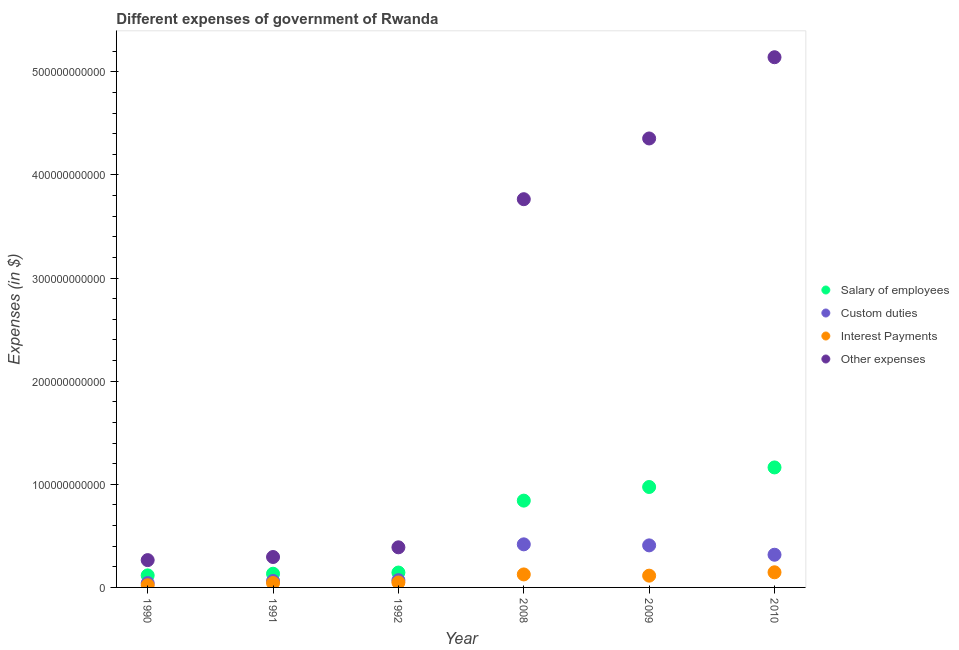What is the amount spent on other expenses in 2010?
Your answer should be very brief. 5.14e+11. Across all years, what is the maximum amount spent on interest payments?
Your answer should be compact. 1.47e+1. Across all years, what is the minimum amount spent on interest payments?
Provide a succinct answer. 2.13e+09. In which year was the amount spent on custom duties maximum?
Ensure brevity in your answer.  2008. What is the total amount spent on custom duties in the graph?
Ensure brevity in your answer.  1.32e+11. What is the difference between the amount spent on interest payments in 1992 and that in 2009?
Offer a very short reply. -6.61e+09. What is the difference between the amount spent on interest payments in 2010 and the amount spent on salary of employees in 1991?
Give a very brief answer. 1.39e+09. What is the average amount spent on other expenses per year?
Provide a short and direct response. 2.37e+11. In the year 1990, what is the difference between the amount spent on other expenses and amount spent on interest payments?
Offer a terse response. 2.44e+1. What is the ratio of the amount spent on salary of employees in 1991 to that in 1992?
Offer a very short reply. 0.92. What is the difference between the highest and the second highest amount spent on custom duties?
Your answer should be very brief. 9.98e+08. What is the difference between the highest and the lowest amount spent on interest payments?
Give a very brief answer. 1.25e+1. In how many years, is the amount spent on custom duties greater than the average amount spent on custom duties taken over all years?
Give a very brief answer. 3. Does the amount spent on salary of employees monotonically increase over the years?
Your response must be concise. Yes. Is the amount spent on custom duties strictly less than the amount spent on other expenses over the years?
Give a very brief answer. Yes. What is the difference between two consecutive major ticks on the Y-axis?
Your answer should be very brief. 1.00e+11. Are the values on the major ticks of Y-axis written in scientific E-notation?
Offer a very short reply. No. Does the graph contain grids?
Offer a terse response. No. Where does the legend appear in the graph?
Keep it short and to the point. Center right. What is the title of the graph?
Offer a very short reply. Different expenses of government of Rwanda. Does "WHO" appear as one of the legend labels in the graph?
Your response must be concise. No. What is the label or title of the X-axis?
Provide a short and direct response. Year. What is the label or title of the Y-axis?
Give a very brief answer. Expenses (in $). What is the Expenses (in $) in Salary of employees in 1990?
Your response must be concise. 1.17e+1. What is the Expenses (in $) in Custom duties in 1990?
Your response must be concise. 4.21e+09. What is the Expenses (in $) of Interest Payments in 1990?
Provide a short and direct response. 2.13e+09. What is the Expenses (in $) of Other expenses in 1990?
Your answer should be very brief. 2.65e+1. What is the Expenses (in $) of Salary of employees in 1991?
Provide a succinct answer. 1.33e+1. What is the Expenses (in $) of Custom duties in 1991?
Provide a short and direct response. 6.24e+09. What is the Expenses (in $) of Interest Payments in 1991?
Your answer should be compact. 4.29e+09. What is the Expenses (in $) in Other expenses in 1991?
Offer a terse response. 2.95e+1. What is the Expenses (in $) of Salary of employees in 1992?
Your answer should be compact. 1.44e+1. What is the Expenses (in $) of Custom duties in 1992?
Your answer should be very brief. 7.04e+09. What is the Expenses (in $) in Interest Payments in 1992?
Your answer should be very brief. 4.80e+09. What is the Expenses (in $) in Other expenses in 1992?
Your answer should be compact. 3.89e+1. What is the Expenses (in $) in Salary of employees in 2008?
Your answer should be compact. 8.42e+1. What is the Expenses (in $) of Custom duties in 2008?
Offer a very short reply. 4.18e+1. What is the Expenses (in $) of Interest Payments in 2008?
Make the answer very short. 1.26e+1. What is the Expenses (in $) of Other expenses in 2008?
Ensure brevity in your answer.  3.77e+11. What is the Expenses (in $) in Salary of employees in 2009?
Your answer should be very brief. 9.74e+1. What is the Expenses (in $) of Custom duties in 2009?
Offer a terse response. 4.08e+1. What is the Expenses (in $) in Interest Payments in 2009?
Make the answer very short. 1.14e+1. What is the Expenses (in $) in Other expenses in 2009?
Give a very brief answer. 4.35e+11. What is the Expenses (in $) in Salary of employees in 2010?
Provide a succinct answer. 1.16e+11. What is the Expenses (in $) of Custom duties in 2010?
Provide a short and direct response. 3.17e+1. What is the Expenses (in $) of Interest Payments in 2010?
Your response must be concise. 1.47e+1. What is the Expenses (in $) of Other expenses in 2010?
Ensure brevity in your answer.  5.14e+11. Across all years, what is the maximum Expenses (in $) of Salary of employees?
Offer a terse response. 1.16e+11. Across all years, what is the maximum Expenses (in $) of Custom duties?
Your response must be concise. 4.18e+1. Across all years, what is the maximum Expenses (in $) in Interest Payments?
Make the answer very short. 1.47e+1. Across all years, what is the maximum Expenses (in $) in Other expenses?
Make the answer very short. 5.14e+11. Across all years, what is the minimum Expenses (in $) in Salary of employees?
Your answer should be compact. 1.17e+1. Across all years, what is the minimum Expenses (in $) in Custom duties?
Provide a short and direct response. 4.21e+09. Across all years, what is the minimum Expenses (in $) of Interest Payments?
Provide a succinct answer. 2.13e+09. Across all years, what is the minimum Expenses (in $) of Other expenses?
Keep it short and to the point. 2.65e+1. What is the total Expenses (in $) in Salary of employees in the graph?
Offer a terse response. 3.37e+11. What is the total Expenses (in $) in Custom duties in the graph?
Your answer should be compact. 1.32e+11. What is the total Expenses (in $) of Interest Payments in the graph?
Keep it short and to the point. 4.99e+1. What is the total Expenses (in $) in Other expenses in the graph?
Ensure brevity in your answer.  1.42e+12. What is the difference between the Expenses (in $) in Salary of employees in 1990 and that in 1991?
Your answer should be very brief. -1.61e+09. What is the difference between the Expenses (in $) in Custom duties in 1990 and that in 1991?
Keep it short and to the point. -2.04e+09. What is the difference between the Expenses (in $) of Interest Payments in 1990 and that in 1991?
Your answer should be compact. -2.16e+09. What is the difference between the Expenses (in $) of Other expenses in 1990 and that in 1991?
Your response must be concise. -3.02e+09. What is the difference between the Expenses (in $) of Salary of employees in 1990 and that in 1992?
Your response must be concise. -2.76e+09. What is the difference between the Expenses (in $) in Custom duties in 1990 and that in 1992?
Offer a very short reply. -2.84e+09. What is the difference between the Expenses (in $) of Interest Payments in 1990 and that in 1992?
Offer a terse response. -2.67e+09. What is the difference between the Expenses (in $) of Other expenses in 1990 and that in 1992?
Make the answer very short. -1.24e+1. What is the difference between the Expenses (in $) in Salary of employees in 1990 and that in 2008?
Make the answer very short. -7.25e+1. What is the difference between the Expenses (in $) of Custom duties in 1990 and that in 2008?
Offer a very short reply. -3.76e+1. What is the difference between the Expenses (in $) of Interest Payments in 1990 and that in 2008?
Give a very brief answer. -1.05e+1. What is the difference between the Expenses (in $) of Other expenses in 1990 and that in 2008?
Your answer should be very brief. -3.50e+11. What is the difference between the Expenses (in $) in Salary of employees in 1990 and that in 2009?
Give a very brief answer. -8.57e+1. What is the difference between the Expenses (in $) in Custom duties in 1990 and that in 2009?
Give a very brief answer. -3.66e+1. What is the difference between the Expenses (in $) in Interest Payments in 1990 and that in 2009?
Your response must be concise. -9.28e+09. What is the difference between the Expenses (in $) of Other expenses in 1990 and that in 2009?
Your answer should be very brief. -4.09e+11. What is the difference between the Expenses (in $) in Salary of employees in 1990 and that in 2010?
Offer a very short reply. -1.05e+11. What is the difference between the Expenses (in $) in Custom duties in 1990 and that in 2010?
Keep it short and to the point. -2.75e+1. What is the difference between the Expenses (in $) of Interest Payments in 1990 and that in 2010?
Keep it short and to the point. -1.25e+1. What is the difference between the Expenses (in $) in Other expenses in 1990 and that in 2010?
Provide a short and direct response. -4.88e+11. What is the difference between the Expenses (in $) in Salary of employees in 1991 and that in 1992?
Make the answer very short. -1.14e+09. What is the difference between the Expenses (in $) in Custom duties in 1991 and that in 1992?
Your answer should be compact. -7.98e+08. What is the difference between the Expenses (in $) of Interest Payments in 1991 and that in 1992?
Provide a short and direct response. -5.08e+08. What is the difference between the Expenses (in $) in Other expenses in 1991 and that in 1992?
Give a very brief answer. -9.40e+09. What is the difference between the Expenses (in $) in Salary of employees in 1991 and that in 2008?
Make the answer very short. -7.09e+1. What is the difference between the Expenses (in $) in Custom duties in 1991 and that in 2008?
Your answer should be very brief. -3.55e+1. What is the difference between the Expenses (in $) in Interest Payments in 1991 and that in 2008?
Make the answer very short. -8.32e+09. What is the difference between the Expenses (in $) in Other expenses in 1991 and that in 2008?
Ensure brevity in your answer.  -3.47e+11. What is the difference between the Expenses (in $) of Salary of employees in 1991 and that in 2009?
Provide a succinct answer. -8.41e+1. What is the difference between the Expenses (in $) in Custom duties in 1991 and that in 2009?
Ensure brevity in your answer.  -3.45e+1. What is the difference between the Expenses (in $) in Interest Payments in 1991 and that in 2009?
Offer a very short reply. -7.12e+09. What is the difference between the Expenses (in $) of Other expenses in 1991 and that in 2009?
Offer a very short reply. -4.06e+11. What is the difference between the Expenses (in $) of Salary of employees in 1991 and that in 2010?
Give a very brief answer. -1.03e+11. What is the difference between the Expenses (in $) in Custom duties in 1991 and that in 2010?
Ensure brevity in your answer.  -2.55e+1. What is the difference between the Expenses (in $) in Interest Payments in 1991 and that in 2010?
Make the answer very short. -1.04e+1. What is the difference between the Expenses (in $) in Other expenses in 1991 and that in 2010?
Your response must be concise. -4.85e+11. What is the difference between the Expenses (in $) in Salary of employees in 1992 and that in 2008?
Your answer should be very brief. -6.97e+1. What is the difference between the Expenses (in $) of Custom duties in 1992 and that in 2008?
Ensure brevity in your answer.  -3.47e+1. What is the difference between the Expenses (in $) in Interest Payments in 1992 and that in 2008?
Give a very brief answer. -7.81e+09. What is the difference between the Expenses (in $) of Other expenses in 1992 and that in 2008?
Offer a terse response. -3.38e+11. What is the difference between the Expenses (in $) of Salary of employees in 1992 and that in 2009?
Provide a succinct answer. -8.30e+1. What is the difference between the Expenses (in $) in Custom duties in 1992 and that in 2009?
Give a very brief answer. -3.37e+1. What is the difference between the Expenses (in $) of Interest Payments in 1992 and that in 2009?
Give a very brief answer. -6.61e+09. What is the difference between the Expenses (in $) in Other expenses in 1992 and that in 2009?
Give a very brief answer. -3.97e+11. What is the difference between the Expenses (in $) of Salary of employees in 1992 and that in 2010?
Your answer should be very brief. -1.02e+11. What is the difference between the Expenses (in $) in Custom duties in 1992 and that in 2010?
Provide a short and direct response. -2.47e+1. What is the difference between the Expenses (in $) of Interest Payments in 1992 and that in 2010?
Offer a very short reply. -9.88e+09. What is the difference between the Expenses (in $) in Other expenses in 1992 and that in 2010?
Provide a succinct answer. -4.75e+11. What is the difference between the Expenses (in $) in Salary of employees in 2008 and that in 2009?
Make the answer very short. -1.32e+1. What is the difference between the Expenses (in $) in Custom duties in 2008 and that in 2009?
Ensure brevity in your answer.  9.98e+08. What is the difference between the Expenses (in $) of Interest Payments in 2008 and that in 2009?
Your answer should be very brief. 1.20e+09. What is the difference between the Expenses (in $) in Other expenses in 2008 and that in 2009?
Offer a terse response. -5.89e+1. What is the difference between the Expenses (in $) of Salary of employees in 2008 and that in 2010?
Give a very brief answer. -3.22e+1. What is the difference between the Expenses (in $) of Custom duties in 2008 and that in 2010?
Ensure brevity in your answer.  1.01e+1. What is the difference between the Expenses (in $) in Interest Payments in 2008 and that in 2010?
Provide a succinct answer. -2.06e+09. What is the difference between the Expenses (in $) of Other expenses in 2008 and that in 2010?
Your answer should be very brief. -1.38e+11. What is the difference between the Expenses (in $) in Salary of employees in 2009 and that in 2010?
Your response must be concise. -1.90e+1. What is the difference between the Expenses (in $) of Custom duties in 2009 and that in 2010?
Offer a very short reply. 9.08e+09. What is the difference between the Expenses (in $) in Interest Payments in 2009 and that in 2010?
Keep it short and to the point. -3.26e+09. What is the difference between the Expenses (in $) of Other expenses in 2009 and that in 2010?
Keep it short and to the point. -7.88e+1. What is the difference between the Expenses (in $) of Salary of employees in 1990 and the Expenses (in $) of Custom duties in 1991?
Provide a succinct answer. 5.44e+09. What is the difference between the Expenses (in $) in Salary of employees in 1990 and the Expenses (in $) in Interest Payments in 1991?
Your response must be concise. 7.39e+09. What is the difference between the Expenses (in $) in Salary of employees in 1990 and the Expenses (in $) in Other expenses in 1991?
Ensure brevity in your answer.  -1.78e+1. What is the difference between the Expenses (in $) of Custom duties in 1990 and the Expenses (in $) of Interest Payments in 1991?
Ensure brevity in your answer.  -8.60e+07. What is the difference between the Expenses (in $) of Custom duties in 1990 and the Expenses (in $) of Other expenses in 1991?
Make the answer very short. -2.53e+1. What is the difference between the Expenses (in $) of Interest Payments in 1990 and the Expenses (in $) of Other expenses in 1991?
Make the answer very short. -2.74e+1. What is the difference between the Expenses (in $) of Salary of employees in 1990 and the Expenses (in $) of Custom duties in 1992?
Offer a terse response. 4.64e+09. What is the difference between the Expenses (in $) in Salary of employees in 1990 and the Expenses (in $) in Interest Payments in 1992?
Offer a very short reply. 6.88e+09. What is the difference between the Expenses (in $) of Salary of employees in 1990 and the Expenses (in $) of Other expenses in 1992?
Ensure brevity in your answer.  -2.72e+1. What is the difference between the Expenses (in $) in Custom duties in 1990 and the Expenses (in $) in Interest Payments in 1992?
Make the answer very short. -5.94e+08. What is the difference between the Expenses (in $) in Custom duties in 1990 and the Expenses (in $) in Other expenses in 1992?
Provide a succinct answer. -3.47e+1. What is the difference between the Expenses (in $) in Interest Payments in 1990 and the Expenses (in $) in Other expenses in 1992?
Provide a short and direct response. -3.68e+1. What is the difference between the Expenses (in $) in Salary of employees in 1990 and the Expenses (in $) in Custom duties in 2008?
Provide a succinct answer. -3.01e+1. What is the difference between the Expenses (in $) in Salary of employees in 1990 and the Expenses (in $) in Interest Payments in 2008?
Give a very brief answer. -9.32e+08. What is the difference between the Expenses (in $) of Salary of employees in 1990 and the Expenses (in $) of Other expenses in 2008?
Make the answer very short. -3.65e+11. What is the difference between the Expenses (in $) of Custom duties in 1990 and the Expenses (in $) of Interest Payments in 2008?
Provide a succinct answer. -8.41e+09. What is the difference between the Expenses (in $) of Custom duties in 1990 and the Expenses (in $) of Other expenses in 2008?
Ensure brevity in your answer.  -3.72e+11. What is the difference between the Expenses (in $) of Interest Payments in 1990 and the Expenses (in $) of Other expenses in 2008?
Provide a short and direct response. -3.74e+11. What is the difference between the Expenses (in $) of Salary of employees in 1990 and the Expenses (in $) of Custom duties in 2009?
Provide a succinct answer. -2.91e+1. What is the difference between the Expenses (in $) in Salary of employees in 1990 and the Expenses (in $) in Interest Payments in 2009?
Your response must be concise. 2.68e+08. What is the difference between the Expenses (in $) in Salary of employees in 1990 and the Expenses (in $) in Other expenses in 2009?
Give a very brief answer. -4.24e+11. What is the difference between the Expenses (in $) of Custom duties in 1990 and the Expenses (in $) of Interest Payments in 2009?
Offer a terse response. -7.21e+09. What is the difference between the Expenses (in $) of Custom duties in 1990 and the Expenses (in $) of Other expenses in 2009?
Provide a short and direct response. -4.31e+11. What is the difference between the Expenses (in $) of Interest Payments in 1990 and the Expenses (in $) of Other expenses in 2009?
Offer a terse response. -4.33e+11. What is the difference between the Expenses (in $) in Salary of employees in 1990 and the Expenses (in $) in Custom duties in 2010?
Offer a terse response. -2.00e+1. What is the difference between the Expenses (in $) in Salary of employees in 1990 and the Expenses (in $) in Interest Payments in 2010?
Provide a succinct answer. -3.00e+09. What is the difference between the Expenses (in $) in Salary of employees in 1990 and the Expenses (in $) in Other expenses in 2010?
Give a very brief answer. -5.03e+11. What is the difference between the Expenses (in $) of Custom duties in 1990 and the Expenses (in $) of Interest Payments in 2010?
Ensure brevity in your answer.  -1.05e+1. What is the difference between the Expenses (in $) in Custom duties in 1990 and the Expenses (in $) in Other expenses in 2010?
Your response must be concise. -5.10e+11. What is the difference between the Expenses (in $) of Interest Payments in 1990 and the Expenses (in $) of Other expenses in 2010?
Offer a very short reply. -5.12e+11. What is the difference between the Expenses (in $) in Salary of employees in 1991 and the Expenses (in $) in Custom duties in 1992?
Your answer should be very brief. 6.25e+09. What is the difference between the Expenses (in $) of Salary of employees in 1991 and the Expenses (in $) of Interest Payments in 1992?
Offer a terse response. 8.49e+09. What is the difference between the Expenses (in $) in Salary of employees in 1991 and the Expenses (in $) in Other expenses in 1992?
Your response must be concise. -2.56e+1. What is the difference between the Expenses (in $) in Custom duties in 1991 and the Expenses (in $) in Interest Payments in 1992?
Keep it short and to the point. 1.44e+09. What is the difference between the Expenses (in $) in Custom duties in 1991 and the Expenses (in $) in Other expenses in 1992?
Provide a succinct answer. -3.27e+1. What is the difference between the Expenses (in $) in Interest Payments in 1991 and the Expenses (in $) in Other expenses in 1992?
Your answer should be very brief. -3.46e+1. What is the difference between the Expenses (in $) of Salary of employees in 1991 and the Expenses (in $) of Custom duties in 2008?
Offer a very short reply. -2.85e+1. What is the difference between the Expenses (in $) of Salary of employees in 1991 and the Expenses (in $) of Interest Payments in 2008?
Provide a short and direct response. 6.78e+08. What is the difference between the Expenses (in $) in Salary of employees in 1991 and the Expenses (in $) in Other expenses in 2008?
Give a very brief answer. -3.63e+11. What is the difference between the Expenses (in $) of Custom duties in 1991 and the Expenses (in $) of Interest Payments in 2008?
Offer a very short reply. -6.37e+09. What is the difference between the Expenses (in $) in Custom duties in 1991 and the Expenses (in $) in Other expenses in 2008?
Your response must be concise. -3.70e+11. What is the difference between the Expenses (in $) in Interest Payments in 1991 and the Expenses (in $) in Other expenses in 2008?
Your answer should be very brief. -3.72e+11. What is the difference between the Expenses (in $) of Salary of employees in 1991 and the Expenses (in $) of Custom duties in 2009?
Ensure brevity in your answer.  -2.75e+1. What is the difference between the Expenses (in $) in Salary of employees in 1991 and the Expenses (in $) in Interest Payments in 2009?
Your answer should be very brief. 1.88e+09. What is the difference between the Expenses (in $) of Salary of employees in 1991 and the Expenses (in $) of Other expenses in 2009?
Keep it short and to the point. -4.22e+11. What is the difference between the Expenses (in $) in Custom duties in 1991 and the Expenses (in $) in Interest Payments in 2009?
Make the answer very short. -5.17e+09. What is the difference between the Expenses (in $) in Custom duties in 1991 and the Expenses (in $) in Other expenses in 2009?
Your response must be concise. -4.29e+11. What is the difference between the Expenses (in $) in Interest Payments in 1991 and the Expenses (in $) in Other expenses in 2009?
Offer a very short reply. -4.31e+11. What is the difference between the Expenses (in $) of Salary of employees in 1991 and the Expenses (in $) of Custom duties in 2010?
Your answer should be compact. -1.84e+1. What is the difference between the Expenses (in $) in Salary of employees in 1991 and the Expenses (in $) in Interest Payments in 2010?
Provide a succinct answer. -1.39e+09. What is the difference between the Expenses (in $) of Salary of employees in 1991 and the Expenses (in $) of Other expenses in 2010?
Offer a terse response. -5.01e+11. What is the difference between the Expenses (in $) in Custom duties in 1991 and the Expenses (in $) in Interest Payments in 2010?
Keep it short and to the point. -8.43e+09. What is the difference between the Expenses (in $) of Custom duties in 1991 and the Expenses (in $) of Other expenses in 2010?
Offer a very short reply. -5.08e+11. What is the difference between the Expenses (in $) in Interest Payments in 1991 and the Expenses (in $) in Other expenses in 2010?
Give a very brief answer. -5.10e+11. What is the difference between the Expenses (in $) of Salary of employees in 1992 and the Expenses (in $) of Custom duties in 2008?
Your response must be concise. -2.73e+1. What is the difference between the Expenses (in $) of Salary of employees in 1992 and the Expenses (in $) of Interest Payments in 2008?
Give a very brief answer. 1.82e+09. What is the difference between the Expenses (in $) of Salary of employees in 1992 and the Expenses (in $) of Other expenses in 2008?
Your answer should be compact. -3.62e+11. What is the difference between the Expenses (in $) of Custom duties in 1992 and the Expenses (in $) of Interest Payments in 2008?
Your answer should be compact. -5.57e+09. What is the difference between the Expenses (in $) in Custom duties in 1992 and the Expenses (in $) in Other expenses in 2008?
Your answer should be very brief. -3.69e+11. What is the difference between the Expenses (in $) of Interest Payments in 1992 and the Expenses (in $) of Other expenses in 2008?
Ensure brevity in your answer.  -3.72e+11. What is the difference between the Expenses (in $) of Salary of employees in 1992 and the Expenses (in $) of Custom duties in 2009?
Your response must be concise. -2.63e+1. What is the difference between the Expenses (in $) of Salary of employees in 1992 and the Expenses (in $) of Interest Payments in 2009?
Provide a succinct answer. 3.02e+09. What is the difference between the Expenses (in $) of Salary of employees in 1992 and the Expenses (in $) of Other expenses in 2009?
Offer a terse response. -4.21e+11. What is the difference between the Expenses (in $) of Custom duties in 1992 and the Expenses (in $) of Interest Payments in 2009?
Your response must be concise. -4.37e+09. What is the difference between the Expenses (in $) of Custom duties in 1992 and the Expenses (in $) of Other expenses in 2009?
Offer a very short reply. -4.28e+11. What is the difference between the Expenses (in $) of Interest Payments in 1992 and the Expenses (in $) of Other expenses in 2009?
Your answer should be very brief. -4.31e+11. What is the difference between the Expenses (in $) in Salary of employees in 1992 and the Expenses (in $) in Custom duties in 2010?
Offer a very short reply. -1.73e+1. What is the difference between the Expenses (in $) in Salary of employees in 1992 and the Expenses (in $) in Interest Payments in 2010?
Provide a succinct answer. -2.40e+08. What is the difference between the Expenses (in $) of Salary of employees in 1992 and the Expenses (in $) of Other expenses in 2010?
Ensure brevity in your answer.  -5.00e+11. What is the difference between the Expenses (in $) in Custom duties in 1992 and the Expenses (in $) in Interest Payments in 2010?
Your response must be concise. -7.63e+09. What is the difference between the Expenses (in $) in Custom duties in 1992 and the Expenses (in $) in Other expenses in 2010?
Give a very brief answer. -5.07e+11. What is the difference between the Expenses (in $) of Interest Payments in 1992 and the Expenses (in $) of Other expenses in 2010?
Provide a short and direct response. -5.09e+11. What is the difference between the Expenses (in $) in Salary of employees in 2008 and the Expenses (in $) in Custom duties in 2009?
Offer a very short reply. 4.34e+1. What is the difference between the Expenses (in $) in Salary of employees in 2008 and the Expenses (in $) in Interest Payments in 2009?
Provide a succinct answer. 7.28e+1. What is the difference between the Expenses (in $) in Salary of employees in 2008 and the Expenses (in $) in Other expenses in 2009?
Give a very brief answer. -3.51e+11. What is the difference between the Expenses (in $) of Custom duties in 2008 and the Expenses (in $) of Interest Payments in 2009?
Ensure brevity in your answer.  3.04e+1. What is the difference between the Expenses (in $) of Custom duties in 2008 and the Expenses (in $) of Other expenses in 2009?
Offer a terse response. -3.94e+11. What is the difference between the Expenses (in $) in Interest Payments in 2008 and the Expenses (in $) in Other expenses in 2009?
Make the answer very short. -4.23e+11. What is the difference between the Expenses (in $) in Salary of employees in 2008 and the Expenses (in $) in Custom duties in 2010?
Offer a terse response. 5.25e+1. What is the difference between the Expenses (in $) of Salary of employees in 2008 and the Expenses (in $) of Interest Payments in 2010?
Your answer should be very brief. 6.95e+1. What is the difference between the Expenses (in $) in Salary of employees in 2008 and the Expenses (in $) in Other expenses in 2010?
Make the answer very short. -4.30e+11. What is the difference between the Expenses (in $) of Custom duties in 2008 and the Expenses (in $) of Interest Payments in 2010?
Make the answer very short. 2.71e+1. What is the difference between the Expenses (in $) of Custom duties in 2008 and the Expenses (in $) of Other expenses in 2010?
Provide a short and direct response. -4.72e+11. What is the difference between the Expenses (in $) in Interest Payments in 2008 and the Expenses (in $) in Other expenses in 2010?
Your answer should be very brief. -5.02e+11. What is the difference between the Expenses (in $) in Salary of employees in 2009 and the Expenses (in $) in Custom duties in 2010?
Your answer should be compact. 6.57e+1. What is the difference between the Expenses (in $) in Salary of employees in 2009 and the Expenses (in $) in Interest Payments in 2010?
Your answer should be compact. 8.27e+1. What is the difference between the Expenses (in $) of Salary of employees in 2009 and the Expenses (in $) of Other expenses in 2010?
Ensure brevity in your answer.  -4.17e+11. What is the difference between the Expenses (in $) in Custom duties in 2009 and the Expenses (in $) in Interest Payments in 2010?
Offer a terse response. 2.61e+1. What is the difference between the Expenses (in $) in Custom duties in 2009 and the Expenses (in $) in Other expenses in 2010?
Offer a very short reply. -4.73e+11. What is the difference between the Expenses (in $) of Interest Payments in 2009 and the Expenses (in $) of Other expenses in 2010?
Offer a very short reply. -5.03e+11. What is the average Expenses (in $) of Salary of employees per year?
Your answer should be very brief. 5.62e+1. What is the average Expenses (in $) of Custom duties per year?
Your response must be concise. 2.20e+1. What is the average Expenses (in $) of Interest Payments per year?
Your answer should be very brief. 8.32e+09. What is the average Expenses (in $) in Other expenses per year?
Provide a succinct answer. 2.37e+11. In the year 1990, what is the difference between the Expenses (in $) of Salary of employees and Expenses (in $) of Custom duties?
Give a very brief answer. 7.47e+09. In the year 1990, what is the difference between the Expenses (in $) in Salary of employees and Expenses (in $) in Interest Payments?
Provide a succinct answer. 9.55e+09. In the year 1990, what is the difference between the Expenses (in $) of Salary of employees and Expenses (in $) of Other expenses?
Offer a very short reply. -1.48e+1. In the year 1990, what is the difference between the Expenses (in $) in Custom duties and Expenses (in $) in Interest Payments?
Offer a terse response. 2.08e+09. In the year 1990, what is the difference between the Expenses (in $) of Custom duties and Expenses (in $) of Other expenses?
Make the answer very short. -2.23e+1. In the year 1990, what is the difference between the Expenses (in $) in Interest Payments and Expenses (in $) in Other expenses?
Provide a succinct answer. -2.44e+1. In the year 1991, what is the difference between the Expenses (in $) of Salary of employees and Expenses (in $) of Custom duties?
Offer a terse response. 7.05e+09. In the year 1991, what is the difference between the Expenses (in $) of Salary of employees and Expenses (in $) of Interest Payments?
Give a very brief answer. 9.00e+09. In the year 1991, what is the difference between the Expenses (in $) in Salary of employees and Expenses (in $) in Other expenses?
Your response must be concise. -1.62e+1. In the year 1991, what is the difference between the Expenses (in $) in Custom duties and Expenses (in $) in Interest Payments?
Ensure brevity in your answer.  1.95e+09. In the year 1991, what is the difference between the Expenses (in $) in Custom duties and Expenses (in $) in Other expenses?
Provide a succinct answer. -2.33e+1. In the year 1991, what is the difference between the Expenses (in $) in Interest Payments and Expenses (in $) in Other expenses?
Your answer should be compact. -2.52e+1. In the year 1992, what is the difference between the Expenses (in $) of Salary of employees and Expenses (in $) of Custom duties?
Provide a succinct answer. 7.39e+09. In the year 1992, what is the difference between the Expenses (in $) in Salary of employees and Expenses (in $) in Interest Payments?
Give a very brief answer. 9.64e+09. In the year 1992, what is the difference between the Expenses (in $) of Salary of employees and Expenses (in $) of Other expenses?
Ensure brevity in your answer.  -2.45e+1. In the year 1992, what is the difference between the Expenses (in $) in Custom duties and Expenses (in $) in Interest Payments?
Provide a succinct answer. 2.24e+09. In the year 1992, what is the difference between the Expenses (in $) of Custom duties and Expenses (in $) of Other expenses?
Your response must be concise. -3.19e+1. In the year 1992, what is the difference between the Expenses (in $) in Interest Payments and Expenses (in $) in Other expenses?
Offer a very short reply. -3.41e+1. In the year 2008, what is the difference between the Expenses (in $) of Salary of employees and Expenses (in $) of Custom duties?
Provide a short and direct response. 4.24e+1. In the year 2008, what is the difference between the Expenses (in $) of Salary of employees and Expenses (in $) of Interest Payments?
Keep it short and to the point. 7.16e+1. In the year 2008, what is the difference between the Expenses (in $) in Salary of employees and Expenses (in $) in Other expenses?
Provide a short and direct response. -2.92e+11. In the year 2008, what is the difference between the Expenses (in $) in Custom duties and Expenses (in $) in Interest Payments?
Provide a short and direct response. 2.92e+1. In the year 2008, what is the difference between the Expenses (in $) of Custom duties and Expenses (in $) of Other expenses?
Your response must be concise. -3.35e+11. In the year 2008, what is the difference between the Expenses (in $) in Interest Payments and Expenses (in $) in Other expenses?
Offer a very short reply. -3.64e+11. In the year 2009, what is the difference between the Expenses (in $) of Salary of employees and Expenses (in $) of Custom duties?
Your answer should be compact. 5.66e+1. In the year 2009, what is the difference between the Expenses (in $) in Salary of employees and Expenses (in $) in Interest Payments?
Your answer should be compact. 8.60e+1. In the year 2009, what is the difference between the Expenses (in $) of Salary of employees and Expenses (in $) of Other expenses?
Provide a short and direct response. -3.38e+11. In the year 2009, what is the difference between the Expenses (in $) of Custom duties and Expenses (in $) of Interest Payments?
Ensure brevity in your answer.  2.94e+1. In the year 2009, what is the difference between the Expenses (in $) in Custom duties and Expenses (in $) in Other expenses?
Your answer should be very brief. -3.95e+11. In the year 2009, what is the difference between the Expenses (in $) of Interest Payments and Expenses (in $) of Other expenses?
Give a very brief answer. -4.24e+11. In the year 2010, what is the difference between the Expenses (in $) in Salary of employees and Expenses (in $) in Custom duties?
Offer a very short reply. 8.47e+1. In the year 2010, what is the difference between the Expenses (in $) in Salary of employees and Expenses (in $) in Interest Payments?
Provide a short and direct response. 1.02e+11. In the year 2010, what is the difference between the Expenses (in $) in Salary of employees and Expenses (in $) in Other expenses?
Your answer should be very brief. -3.98e+11. In the year 2010, what is the difference between the Expenses (in $) of Custom duties and Expenses (in $) of Interest Payments?
Offer a terse response. 1.70e+1. In the year 2010, what is the difference between the Expenses (in $) of Custom duties and Expenses (in $) of Other expenses?
Your answer should be very brief. -4.83e+11. In the year 2010, what is the difference between the Expenses (in $) in Interest Payments and Expenses (in $) in Other expenses?
Give a very brief answer. -5.00e+11. What is the ratio of the Expenses (in $) in Salary of employees in 1990 to that in 1991?
Give a very brief answer. 0.88. What is the ratio of the Expenses (in $) in Custom duties in 1990 to that in 1991?
Your response must be concise. 0.67. What is the ratio of the Expenses (in $) of Interest Payments in 1990 to that in 1991?
Offer a very short reply. 0.5. What is the ratio of the Expenses (in $) in Other expenses in 1990 to that in 1991?
Give a very brief answer. 0.9. What is the ratio of the Expenses (in $) of Salary of employees in 1990 to that in 1992?
Make the answer very short. 0.81. What is the ratio of the Expenses (in $) of Custom duties in 1990 to that in 1992?
Offer a terse response. 0.6. What is the ratio of the Expenses (in $) in Interest Payments in 1990 to that in 1992?
Offer a very short reply. 0.44. What is the ratio of the Expenses (in $) of Other expenses in 1990 to that in 1992?
Your answer should be compact. 0.68. What is the ratio of the Expenses (in $) in Salary of employees in 1990 to that in 2008?
Give a very brief answer. 0.14. What is the ratio of the Expenses (in $) of Custom duties in 1990 to that in 2008?
Keep it short and to the point. 0.1. What is the ratio of the Expenses (in $) in Interest Payments in 1990 to that in 2008?
Your answer should be compact. 0.17. What is the ratio of the Expenses (in $) in Other expenses in 1990 to that in 2008?
Provide a short and direct response. 0.07. What is the ratio of the Expenses (in $) of Salary of employees in 1990 to that in 2009?
Offer a very short reply. 0.12. What is the ratio of the Expenses (in $) of Custom duties in 1990 to that in 2009?
Your response must be concise. 0.1. What is the ratio of the Expenses (in $) of Interest Payments in 1990 to that in 2009?
Give a very brief answer. 0.19. What is the ratio of the Expenses (in $) in Other expenses in 1990 to that in 2009?
Offer a very short reply. 0.06. What is the ratio of the Expenses (in $) of Salary of employees in 1990 to that in 2010?
Offer a very short reply. 0.1. What is the ratio of the Expenses (in $) of Custom duties in 1990 to that in 2010?
Keep it short and to the point. 0.13. What is the ratio of the Expenses (in $) in Interest Payments in 1990 to that in 2010?
Provide a succinct answer. 0.15. What is the ratio of the Expenses (in $) in Other expenses in 1990 to that in 2010?
Offer a terse response. 0.05. What is the ratio of the Expenses (in $) in Salary of employees in 1991 to that in 1992?
Ensure brevity in your answer.  0.92. What is the ratio of the Expenses (in $) in Custom duties in 1991 to that in 1992?
Offer a very short reply. 0.89. What is the ratio of the Expenses (in $) in Interest Payments in 1991 to that in 1992?
Keep it short and to the point. 0.89. What is the ratio of the Expenses (in $) of Other expenses in 1991 to that in 1992?
Provide a succinct answer. 0.76. What is the ratio of the Expenses (in $) in Salary of employees in 1991 to that in 2008?
Make the answer very short. 0.16. What is the ratio of the Expenses (in $) in Custom duties in 1991 to that in 2008?
Provide a succinct answer. 0.15. What is the ratio of the Expenses (in $) of Interest Payments in 1991 to that in 2008?
Your answer should be very brief. 0.34. What is the ratio of the Expenses (in $) of Other expenses in 1991 to that in 2008?
Ensure brevity in your answer.  0.08. What is the ratio of the Expenses (in $) of Salary of employees in 1991 to that in 2009?
Ensure brevity in your answer.  0.14. What is the ratio of the Expenses (in $) in Custom duties in 1991 to that in 2009?
Provide a short and direct response. 0.15. What is the ratio of the Expenses (in $) in Interest Payments in 1991 to that in 2009?
Provide a short and direct response. 0.38. What is the ratio of the Expenses (in $) in Other expenses in 1991 to that in 2009?
Your answer should be very brief. 0.07. What is the ratio of the Expenses (in $) in Salary of employees in 1991 to that in 2010?
Provide a succinct answer. 0.11. What is the ratio of the Expenses (in $) in Custom duties in 1991 to that in 2010?
Provide a succinct answer. 0.2. What is the ratio of the Expenses (in $) of Interest Payments in 1991 to that in 2010?
Provide a succinct answer. 0.29. What is the ratio of the Expenses (in $) in Other expenses in 1991 to that in 2010?
Give a very brief answer. 0.06. What is the ratio of the Expenses (in $) in Salary of employees in 1992 to that in 2008?
Keep it short and to the point. 0.17. What is the ratio of the Expenses (in $) in Custom duties in 1992 to that in 2008?
Your answer should be very brief. 0.17. What is the ratio of the Expenses (in $) of Interest Payments in 1992 to that in 2008?
Your answer should be very brief. 0.38. What is the ratio of the Expenses (in $) in Other expenses in 1992 to that in 2008?
Keep it short and to the point. 0.1. What is the ratio of the Expenses (in $) of Salary of employees in 1992 to that in 2009?
Your response must be concise. 0.15. What is the ratio of the Expenses (in $) in Custom duties in 1992 to that in 2009?
Your response must be concise. 0.17. What is the ratio of the Expenses (in $) of Interest Payments in 1992 to that in 2009?
Keep it short and to the point. 0.42. What is the ratio of the Expenses (in $) of Other expenses in 1992 to that in 2009?
Your response must be concise. 0.09. What is the ratio of the Expenses (in $) in Salary of employees in 1992 to that in 2010?
Ensure brevity in your answer.  0.12. What is the ratio of the Expenses (in $) in Custom duties in 1992 to that in 2010?
Give a very brief answer. 0.22. What is the ratio of the Expenses (in $) in Interest Payments in 1992 to that in 2010?
Ensure brevity in your answer.  0.33. What is the ratio of the Expenses (in $) of Other expenses in 1992 to that in 2010?
Offer a very short reply. 0.08. What is the ratio of the Expenses (in $) of Salary of employees in 2008 to that in 2009?
Your answer should be compact. 0.86. What is the ratio of the Expenses (in $) of Custom duties in 2008 to that in 2009?
Keep it short and to the point. 1.02. What is the ratio of the Expenses (in $) in Interest Payments in 2008 to that in 2009?
Your response must be concise. 1.11. What is the ratio of the Expenses (in $) in Other expenses in 2008 to that in 2009?
Offer a terse response. 0.86. What is the ratio of the Expenses (in $) in Salary of employees in 2008 to that in 2010?
Offer a very short reply. 0.72. What is the ratio of the Expenses (in $) in Custom duties in 2008 to that in 2010?
Make the answer very short. 1.32. What is the ratio of the Expenses (in $) in Interest Payments in 2008 to that in 2010?
Your answer should be compact. 0.86. What is the ratio of the Expenses (in $) in Other expenses in 2008 to that in 2010?
Provide a short and direct response. 0.73. What is the ratio of the Expenses (in $) in Salary of employees in 2009 to that in 2010?
Your answer should be compact. 0.84. What is the ratio of the Expenses (in $) in Custom duties in 2009 to that in 2010?
Your answer should be very brief. 1.29. What is the ratio of the Expenses (in $) in Interest Payments in 2009 to that in 2010?
Ensure brevity in your answer.  0.78. What is the ratio of the Expenses (in $) of Other expenses in 2009 to that in 2010?
Provide a short and direct response. 0.85. What is the difference between the highest and the second highest Expenses (in $) in Salary of employees?
Your answer should be very brief. 1.90e+1. What is the difference between the highest and the second highest Expenses (in $) in Custom duties?
Your answer should be very brief. 9.98e+08. What is the difference between the highest and the second highest Expenses (in $) in Interest Payments?
Give a very brief answer. 2.06e+09. What is the difference between the highest and the second highest Expenses (in $) of Other expenses?
Your response must be concise. 7.88e+1. What is the difference between the highest and the lowest Expenses (in $) of Salary of employees?
Your response must be concise. 1.05e+11. What is the difference between the highest and the lowest Expenses (in $) of Custom duties?
Ensure brevity in your answer.  3.76e+1. What is the difference between the highest and the lowest Expenses (in $) in Interest Payments?
Offer a terse response. 1.25e+1. What is the difference between the highest and the lowest Expenses (in $) in Other expenses?
Provide a short and direct response. 4.88e+11. 